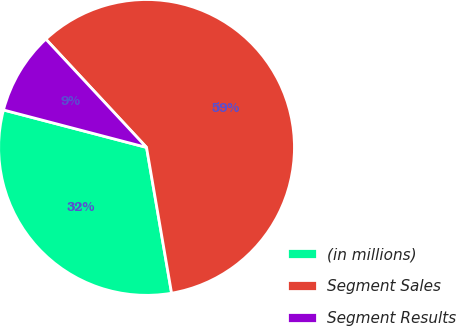Convert chart. <chart><loc_0><loc_0><loc_500><loc_500><pie_chart><fcel>(in millions)<fcel>Segment Sales<fcel>Segment Results<nl><fcel>31.78%<fcel>59.21%<fcel>9.0%<nl></chart> 